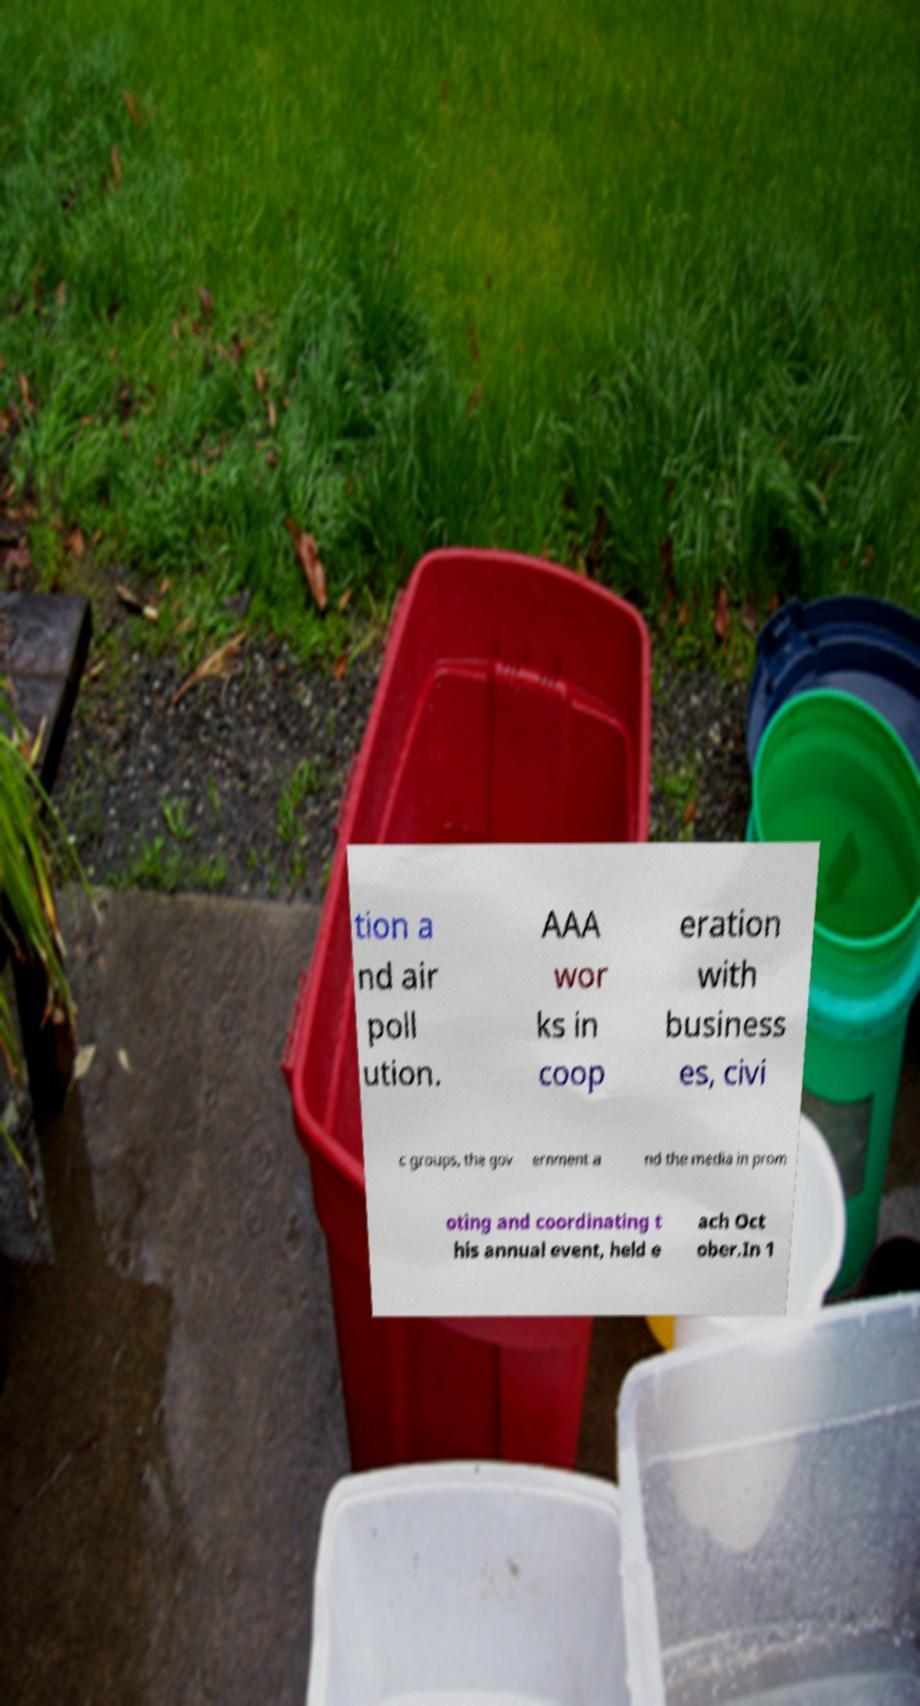Can you accurately transcribe the text from the provided image for me? tion a nd air poll ution. AAA wor ks in coop eration with business es, civi c groups, the gov ernment a nd the media in prom oting and coordinating t his annual event, held e ach Oct ober.In 1 